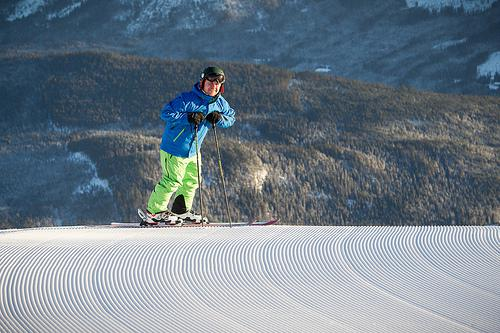Question: where is the man standing?
Choices:
A. On a balcony.
B. In a field.
C. On a mountain.
D. On the snow.
Answer with the letter. Answer: D Question: who is in the picture?
Choices:
A. A runner.
B. A doctor.
C. A skier.
D. A fisherman.
Answer with the letter. Answer: C Question: what color is the ground?
Choices:
A. White.
B. Blue.
C. Grey.
D. Brown.
Answer with the letter. Answer: A Question: why is he standing?
Choices:
A. To catch a ball.
B. To fish.
C. To ski.
D. To recieve orders.
Answer with the letter. Answer: C 